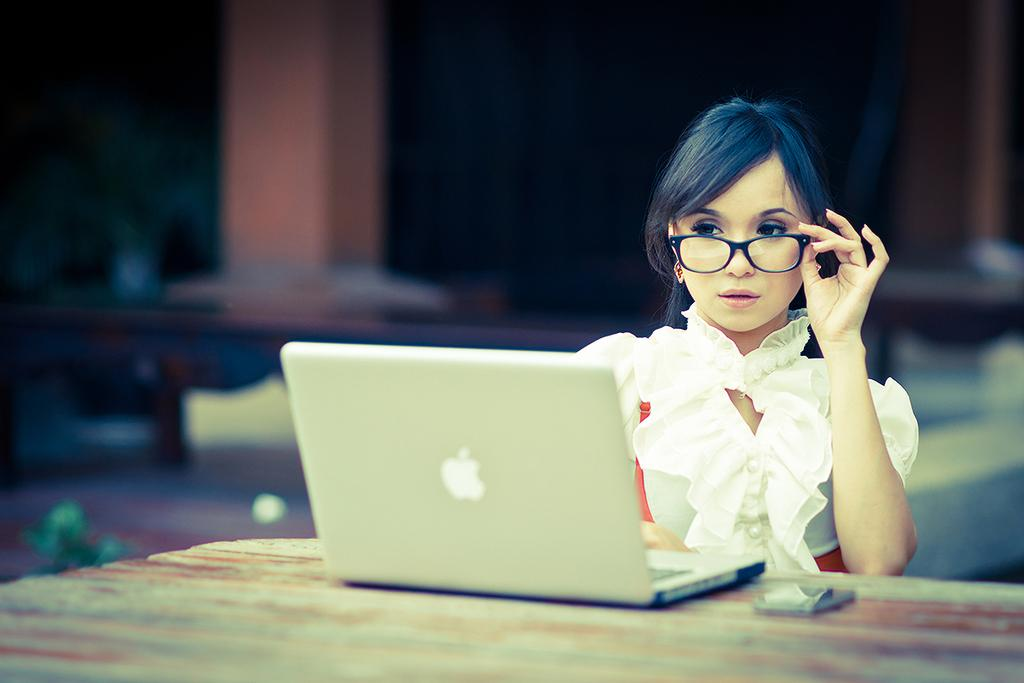What is the person in the image doing? The person is sitting in the image. Where is the person sitting? The person is sitting at a table. What is on the table with the person? There is a laptop and an object on the table. How is the background of the person depicted? The background of the person is blurred. What type of paste is being used by the person in the image? There is no paste visible in the image, and the person is not shown using any paste. 